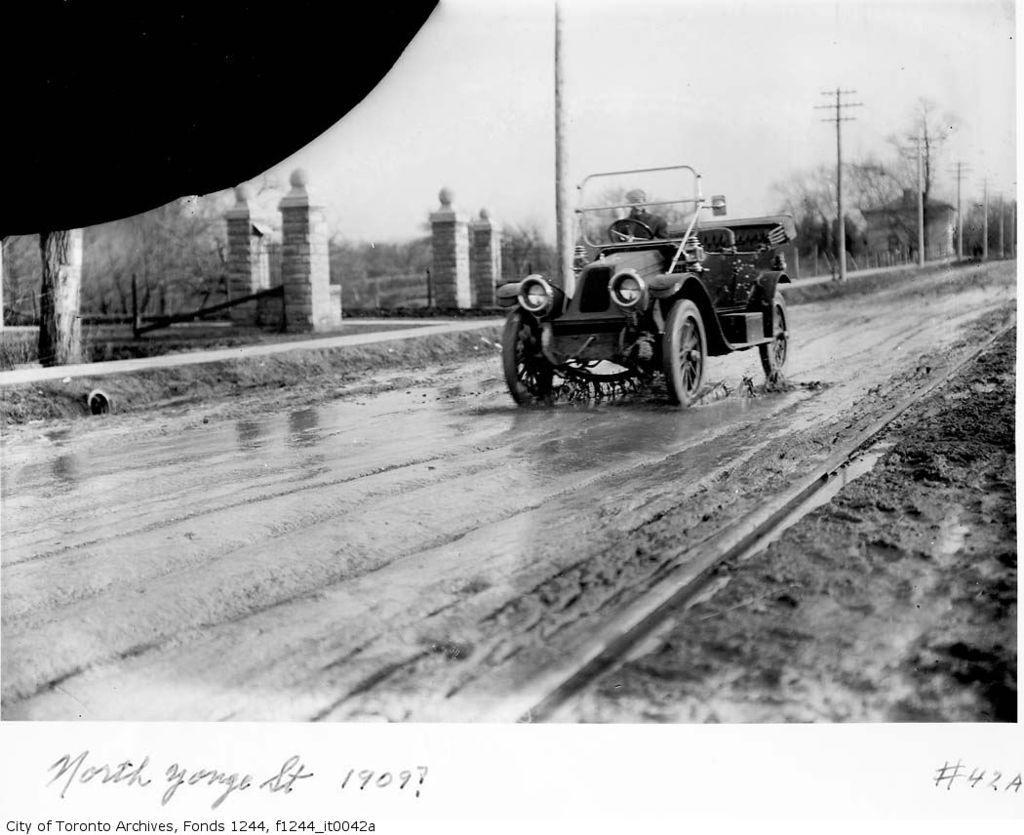How would you summarize this image in a sentence or two? This image consists of a vehicle. In which we can see a person. At the bottom, there is a road. And it looks muddy. In the background, there are pillars along with the trees. At the top, there is sky. 